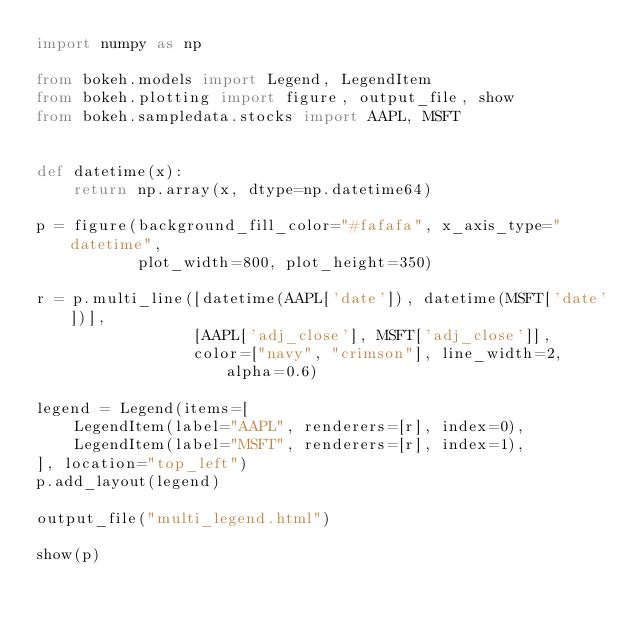Convert code to text. <code><loc_0><loc_0><loc_500><loc_500><_Python_>import numpy as np

from bokeh.models import Legend, LegendItem
from bokeh.plotting import figure, output_file, show
from bokeh.sampledata.stocks import AAPL, MSFT


def datetime(x):
    return np.array(x, dtype=np.datetime64)

p = figure(background_fill_color="#fafafa", x_axis_type="datetime",
           plot_width=800, plot_height=350)

r = p.multi_line([datetime(AAPL['date']), datetime(MSFT['date'])],
                 [AAPL['adj_close'], MSFT['adj_close']],
                 color=["navy", "crimson"], line_width=2, alpha=0.6)

legend = Legend(items=[
    LegendItem(label="AAPL", renderers=[r], index=0),
    LegendItem(label="MSFT", renderers=[r], index=1),
], location="top_left")
p.add_layout(legend)

output_file("multi_legend.html")

show(p)
</code> 